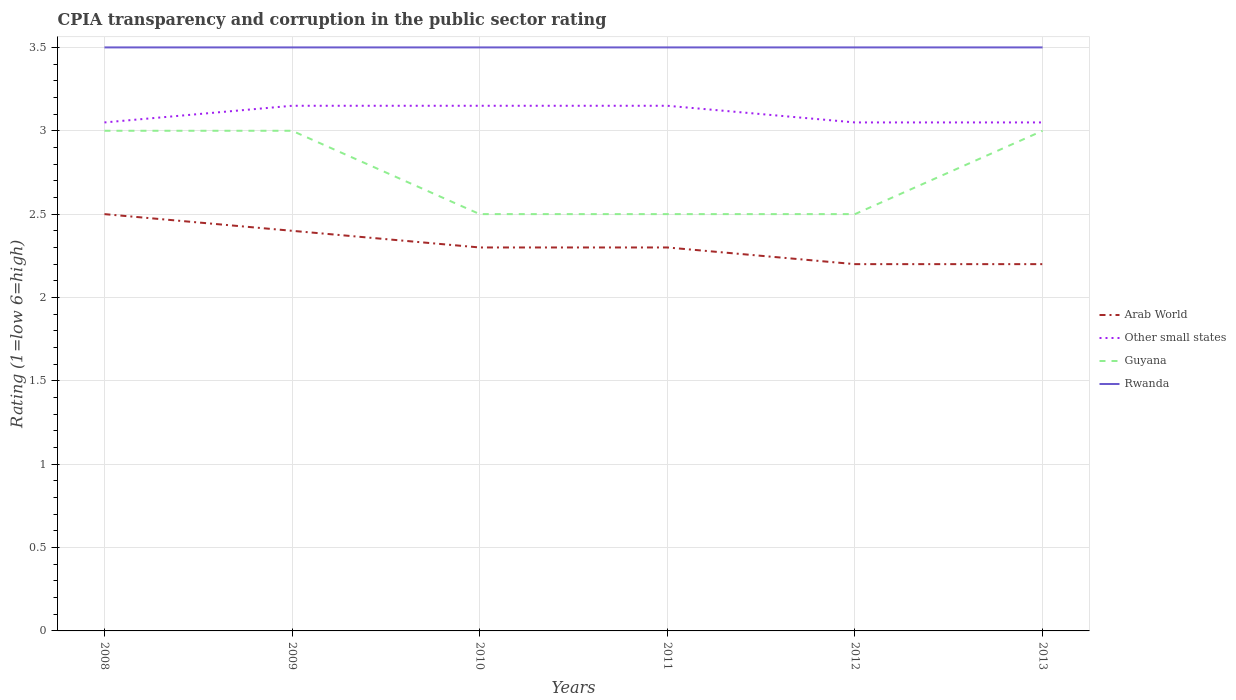Across all years, what is the maximum CPIA rating in Arab World?
Give a very brief answer. 2.2. In which year was the CPIA rating in Arab World maximum?
Your answer should be compact. 2012. What is the total CPIA rating in Arab World in the graph?
Provide a short and direct response. 0.3. What is the difference between the highest and the second highest CPIA rating in Other small states?
Your answer should be compact. 0.1. Is the CPIA rating in Other small states strictly greater than the CPIA rating in Rwanda over the years?
Give a very brief answer. Yes. How many years are there in the graph?
Your answer should be compact. 6. What is the difference between two consecutive major ticks on the Y-axis?
Offer a very short reply. 0.5. Does the graph contain any zero values?
Keep it short and to the point. No. Does the graph contain grids?
Keep it short and to the point. Yes. How are the legend labels stacked?
Your answer should be compact. Vertical. What is the title of the graph?
Ensure brevity in your answer.  CPIA transparency and corruption in the public sector rating. What is the label or title of the Y-axis?
Offer a terse response. Rating (1=low 6=high). What is the Rating (1=low 6=high) of Other small states in 2008?
Offer a very short reply. 3.05. What is the Rating (1=low 6=high) of Guyana in 2008?
Your response must be concise. 3. What is the Rating (1=low 6=high) in Rwanda in 2008?
Provide a succinct answer. 3.5. What is the Rating (1=low 6=high) of Arab World in 2009?
Ensure brevity in your answer.  2.4. What is the Rating (1=low 6=high) of Other small states in 2009?
Provide a succinct answer. 3.15. What is the Rating (1=low 6=high) of Other small states in 2010?
Your answer should be very brief. 3.15. What is the Rating (1=low 6=high) in Other small states in 2011?
Offer a terse response. 3.15. What is the Rating (1=low 6=high) in Guyana in 2011?
Offer a very short reply. 2.5. What is the Rating (1=low 6=high) of Other small states in 2012?
Your answer should be very brief. 3.05. What is the Rating (1=low 6=high) in Rwanda in 2012?
Give a very brief answer. 3.5. What is the Rating (1=low 6=high) in Arab World in 2013?
Offer a very short reply. 2.2. What is the Rating (1=low 6=high) of Other small states in 2013?
Provide a succinct answer. 3.05. What is the Rating (1=low 6=high) of Guyana in 2013?
Provide a succinct answer. 3. Across all years, what is the maximum Rating (1=low 6=high) in Arab World?
Your answer should be very brief. 2.5. Across all years, what is the maximum Rating (1=low 6=high) of Other small states?
Keep it short and to the point. 3.15. Across all years, what is the minimum Rating (1=low 6=high) of Other small states?
Give a very brief answer. 3.05. Across all years, what is the minimum Rating (1=low 6=high) in Guyana?
Offer a very short reply. 2.5. Across all years, what is the minimum Rating (1=low 6=high) of Rwanda?
Offer a very short reply. 3.5. What is the total Rating (1=low 6=high) in Arab World in the graph?
Offer a very short reply. 13.9. What is the total Rating (1=low 6=high) of Guyana in the graph?
Your response must be concise. 16.5. What is the difference between the Rating (1=low 6=high) of Arab World in 2008 and that in 2009?
Your answer should be compact. 0.1. What is the difference between the Rating (1=low 6=high) of Other small states in 2008 and that in 2009?
Provide a short and direct response. -0.1. What is the difference between the Rating (1=low 6=high) in Guyana in 2008 and that in 2009?
Your answer should be compact. 0. What is the difference between the Rating (1=low 6=high) of Rwanda in 2008 and that in 2009?
Ensure brevity in your answer.  0. What is the difference between the Rating (1=low 6=high) of Arab World in 2008 and that in 2010?
Ensure brevity in your answer.  0.2. What is the difference between the Rating (1=low 6=high) of Other small states in 2008 and that in 2010?
Provide a short and direct response. -0.1. What is the difference between the Rating (1=low 6=high) in Guyana in 2008 and that in 2010?
Your response must be concise. 0.5. What is the difference between the Rating (1=low 6=high) in Rwanda in 2008 and that in 2010?
Make the answer very short. 0. What is the difference between the Rating (1=low 6=high) of Other small states in 2008 and that in 2011?
Your response must be concise. -0.1. What is the difference between the Rating (1=low 6=high) of Guyana in 2008 and that in 2011?
Your response must be concise. 0.5. What is the difference between the Rating (1=low 6=high) of Rwanda in 2008 and that in 2011?
Your response must be concise. 0. What is the difference between the Rating (1=low 6=high) in Guyana in 2008 and that in 2012?
Provide a succinct answer. 0.5. What is the difference between the Rating (1=low 6=high) of Arab World in 2008 and that in 2013?
Your answer should be very brief. 0.3. What is the difference between the Rating (1=low 6=high) of Guyana in 2008 and that in 2013?
Provide a succinct answer. 0. What is the difference between the Rating (1=low 6=high) in Rwanda in 2009 and that in 2010?
Provide a succinct answer. 0. What is the difference between the Rating (1=low 6=high) of Arab World in 2009 and that in 2011?
Give a very brief answer. 0.1. What is the difference between the Rating (1=low 6=high) in Other small states in 2009 and that in 2011?
Provide a short and direct response. 0. What is the difference between the Rating (1=low 6=high) in Other small states in 2009 and that in 2012?
Make the answer very short. 0.1. What is the difference between the Rating (1=low 6=high) of Rwanda in 2009 and that in 2012?
Ensure brevity in your answer.  0. What is the difference between the Rating (1=low 6=high) in Arab World in 2009 and that in 2013?
Your answer should be very brief. 0.2. What is the difference between the Rating (1=low 6=high) of Arab World in 2010 and that in 2011?
Your answer should be compact. 0. What is the difference between the Rating (1=low 6=high) in Guyana in 2010 and that in 2012?
Offer a very short reply. 0. What is the difference between the Rating (1=low 6=high) of Other small states in 2010 and that in 2013?
Offer a very short reply. 0.1. What is the difference between the Rating (1=low 6=high) of Rwanda in 2010 and that in 2013?
Your answer should be compact. 0. What is the difference between the Rating (1=low 6=high) of Arab World in 2011 and that in 2012?
Provide a short and direct response. 0.1. What is the difference between the Rating (1=low 6=high) in Other small states in 2011 and that in 2012?
Offer a terse response. 0.1. What is the difference between the Rating (1=low 6=high) of Rwanda in 2011 and that in 2012?
Provide a short and direct response. 0. What is the difference between the Rating (1=low 6=high) in Other small states in 2011 and that in 2013?
Your response must be concise. 0.1. What is the difference between the Rating (1=low 6=high) of Rwanda in 2011 and that in 2013?
Your answer should be very brief. 0. What is the difference between the Rating (1=low 6=high) in Rwanda in 2012 and that in 2013?
Your answer should be compact. 0. What is the difference between the Rating (1=low 6=high) in Arab World in 2008 and the Rating (1=low 6=high) in Other small states in 2009?
Your response must be concise. -0.65. What is the difference between the Rating (1=low 6=high) in Arab World in 2008 and the Rating (1=low 6=high) in Guyana in 2009?
Ensure brevity in your answer.  -0.5. What is the difference between the Rating (1=low 6=high) in Arab World in 2008 and the Rating (1=low 6=high) in Rwanda in 2009?
Provide a succinct answer. -1. What is the difference between the Rating (1=low 6=high) of Other small states in 2008 and the Rating (1=low 6=high) of Rwanda in 2009?
Provide a short and direct response. -0.45. What is the difference between the Rating (1=low 6=high) of Guyana in 2008 and the Rating (1=low 6=high) of Rwanda in 2009?
Offer a terse response. -0.5. What is the difference between the Rating (1=low 6=high) in Arab World in 2008 and the Rating (1=low 6=high) in Other small states in 2010?
Ensure brevity in your answer.  -0.65. What is the difference between the Rating (1=low 6=high) of Arab World in 2008 and the Rating (1=low 6=high) of Guyana in 2010?
Provide a succinct answer. 0. What is the difference between the Rating (1=low 6=high) of Arab World in 2008 and the Rating (1=low 6=high) of Rwanda in 2010?
Your answer should be very brief. -1. What is the difference between the Rating (1=low 6=high) of Other small states in 2008 and the Rating (1=low 6=high) of Guyana in 2010?
Keep it short and to the point. 0.55. What is the difference between the Rating (1=low 6=high) in Other small states in 2008 and the Rating (1=low 6=high) in Rwanda in 2010?
Keep it short and to the point. -0.45. What is the difference between the Rating (1=low 6=high) of Guyana in 2008 and the Rating (1=low 6=high) of Rwanda in 2010?
Your answer should be compact. -0.5. What is the difference between the Rating (1=low 6=high) of Arab World in 2008 and the Rating (1=low 6=high) of Other small states in 2011?
Ensure brevity in your answer.  -0.65. What is the difference between the Rating (1=low 6=high) of Arab World in 2008 and the Rating (1=low 6=high) of Rwanda in 2011?
Offer a terse response. -1. What is the difference between the Rating (1=low 6=high) of Other small states in 2008 and the Rating (1=low 6=high) of Guyana in 2011?
Your response must be concise. 0.55. What is the difference between the Rating (1=low 6=high) in Other small states in 2008 and the Rating (1=low 6=high) in Rwanda in 2011?
Give a very brief answer. -0.45. What is the difference between the Rating (1=low 6=high) of Arab World in 2008 and the Rating (1=low 6=high) of Other small states in 2012?
Your answer should be very brief. -0.55. What is the difference between the Rating (1=low 6=high) in Other small states in 2008 and the Rating (1=low 6=high) in Guyana in 2012?
Offer a terse response. 0.55. What is the difference between the Rating (1=low 6=high) in Other small states in 2008 and the Rating (1=low 6=high) in Rwanda in 2012?
Give a very brief answer. -0.45. What is the difference between the Rating (1=low 6=high) in Arab World in 2008 and the Rating (1=low 6=high) in Other small states in 2013?
Offer a terse response. -0.55. What is the difference between the Rating (1=low 6=high) in Other small states in 2008 and the Rating (1=low 6=high) in Guyana in 2013?
Your answer should be compact. 0.05. What is the difference between the Rating (1=low 6=high) of Other small states in 2008 and the Rating (1=low 6=high) of Rwanda in 2013?
Your answer should be compact. -0.45. What is the difference between the Rating (1=low 6=high) in Guyana in 2008 and the Rating (1=low 6=high) in Rwanda in 2013?
Keep it short and to the point. -0.5. What is the difference between the Rating (1=low 6=high) of Arab World in 2009 and the Rating (1=low 6=high) of Other small states in 2010?
Make the answer very short. -0.75. What is the difference between the Rating (1=low 6=high) in Arab World in 2009 and the Rating (1=low 6=high) in Guyana in 2010?
Offer a very short reply. -0.1. What is the difference between the Rating (1=low 6=high) of Arab World in 2009 and the Rating (1=low 6=high) of Rwanda in 2010?
Provide a succinct answer. -1.1. What is the difference between the Rating (1=low 6=high) of Other small states in 2009 and the Rating (1=low 6=high) of Guyana in 2010?
Ensure brevity in your answer.  0.65. What is the difference between the Rating (1=low 6=high) of Other small states in 2009 and the Rating (1=low 6=high) of Rwanda in 2010?
Your response must be concise. -0.35. What is the difference between the Rating (1=low 6=high) in Guyana in 2009 and the Rating (1=low 6=high) in Rwanda in 2010?
Keep it short and to the point. -0.5. What is the difference between the Rating (1=low 6=high) in Arab World in 2009 and the Rating (1=low 6=high) in Other small states in 2011?
Your answer should be very brief. -0.75. What is the difference between the Rating (1=low 6=high) of Other small states in 2009 and the Rating (1=low 6=high) of Guyana in 2011?
Make the answer very short. 0.65. What is the difference between the Rating (1=low 6=high) in Other small states in 2009 and the Rating (1=low 6=high) in Rwanda in 2011?
Keep it short and to the point. -0.35. What is the difference between the Rating (1=low 6=high) of Guyana in 2009 and the Rating (1=low 6=high) of Rwanda in 2011?
Provide a short and direct response. -0.5. What is the difference between the Rating (1=low 6=high) of Arab World in 2009 and the Rating (1=low 6=high) of Other small states in 2012?
Make the answer very short. -0.65. What is the difference between the Rating (1=low 6=high) in Arab World in 2009 and the Rating (1=low 6=high) in Guyana in 2012?
Provide a short and direct response. -0.1. What is the difference between the Rating (1=low 6=high) in Arab World in 2009 and the Rating (1=low 6=high) in Rwanda in 2012?
Provide a short and direct response. -1.1. What is the difference between the Rating (1=low 6=high) of Other small states in 2009 and the Rating (1=low 6=high) of Guyana in 2012?
Ensure brevity in your answer.  0.65. What is the difference between the Rating (1=low 6=high) in Other small states in 2009 and the Rating (1=low 6=high) in Rwanda in 2012?
Your response must be concise. -0.35. What is the difference between the Rating (1=low 6=high) of Arab World in 2009 and the Rating (1=low 6=high) of Other small states in 2013?
Ensure brevity in your answer.  -0.65. What is the difference between the Rating (1=low 6=high) of Other small states in 2009 and the Rating (1=low 6=high) of Rwanda in 2013?
Your response must be concise. -0.35. What is the difference between the Rating (1=low 6=high) in Guyana in 2009 and the Rating (1=low 6=high) in Rwanda in 2013?
Your answer should be very brief. -0.5. What is the difference between the Rating (1=low 6=high) in Arab World in 2010 and the Rating (1=low 6=high) in Other small states in 2011?
Make the answer very short. -0.85. What is the difference between the Rating (1=low 6=high) of Arab World in 2010 and the Rating (1=low 6=high) of Guyana in 2011?
Your answer should be very brief. -0.2. What is the difference between the Rating (1=low 6=high) of Other small states in 2010 and the Rating (1=low 6=high) of Guyana in 2011?
Your response must be concise. 0.65. What is the difference between the Rating (1=low 6=high) in Other small states in 2010 and the Rating (1=low 6=high) in Rwanda in 2011?
Offer a terse response. -0.35. What is the difference between the Rating (1=low 6=high) in Arab World in 2010 and the Rating (1=low 6=high) in Other small states in 2012?
Your answer should be compact. -0.75. What is the difference between the Rating (1=low 6=high) of Arab World in 2010 and the Rating (1=low 6=high) of Guyana in 2012?
Your answer should be very brief. -0.2. What is the difference between the Rating (1=low 6=high) in Other small states in 2010 and the Rating (1=low 6=high) in Guyana in 2012?
Offer a very short reply. 0.65. What is the difference between the Rating (1=low 6=high) in Other small states in 2010 and the Rating (1=low 6=high) in Rwanda in 2012?
Your response must be concise. -0.35. What is the difference between the Rating (1=low 6=high) in Guyana in 2010 and the Rating (1=low 6=high) in Rwanda in 2012?
Offer a terse response. -1. What is the difference between the Rating (1=low 6=high) of Arab World in 2010 and the Rating (1=low 6=high) of Other small states in 2013?
Provide a short and direct response. -0.75. What is the difference between the Rating (1=low 6=high) of Arab World in 2010 and the Rating (1=low 6=high) of Guyana in 2013?
Keep it short and to the point. -0.7. What is the difference between the Rating (1=low 6=high) of Arab World in 2010 and the Rating (1=low 6=high) of Rwanda in 2013?
Offer a terse response. -1.2. What is the difference between the Rating (1=low 6=high) in Other small states in 2010 and the Rating (1=low 6=high) in Guyana in 2013?
Give a very brief answer. 0.15. What is the difference between the Rating (1=low 6=high) of Other small states in 2010 and the Rating (1=low 6=high) of Rwanda in 2013?
Offer a terse response. -0.35. What is the difference between the Rating (1=low 6=high) in Arab World in 2011 and the Rating (1=low 6=high) in Other small states in 2012?
Make the answer very short. -0.75. What is the difference between the Rating (1=low 6=high) in Other small states in 2011 and the Rating (1=low 6=high) in Guyana in 2012?
Provide a succinct answer. 0.65. What is the difference between the Rating (1=low 6=high) in Other small states in 2011 and the Rating (1=low 6=high) in Rwanda in 2012?
Make the answer very short. -0.35. What is the difference between the Rating (1=low 6=high) of Arab World in 2011 and the Rating (1=low 6=high) of Other small states in 2013?
Give a very brief answer. -0.75. What is the difference between the Rating (1=low 6=high) in Arab World in 2011 and the Rating (1=low 6=high) in Rwanda in 2013?
Offer a terse response. -1.2. What is the difference between the Rating (1=low 6=high) in Other small states in 2011 and the Rating (1=low 6=high) in Rwanda in 2013?
Your answer should be compact. -0.35. What is the difference between the Rating (1=low 6=high) of Arab World in 2012 and the Rating (1=low 6=high) of Other small states in 2013?
Keep it short and to the point. -0.85. What is the difference between the Rating (1=low 6=high) in Other small states in 2012 and the Rating (1=low 6=high) in Guyana in 2013?
Keep it short and to the point. 0.05. What is the difference between the Rating (1=low 6=high) of Other small states in 2012 and the Rating (1=low 6=high) of Rwanda in 2013?
Offer a very short reply. -0.45. What is the average Rating (1=low 6=high) in Arab World per year?
Offer a very short reply. 2.32. What is the average Rating (1=low 6=high) of Guyana per year?
Keep it short and to the point. 2.75. What is the average Rating (1=low 6=high) of Rwanda per year?
Provide a succinct answer. 3.5. In the year 2008, what is the difference between the Rating (1=low 6=high) in Arab World and Rating (1=low 6=high) in Other small states?
Provide a succinct answer. -0.55. In the year 2008, what is the difference between the Rating (1=low 6=high) of Other small states and Rating (1=low 6=high) of Rwanda?
Make the answer very short. -0.45. In the year 2009, what is the difference between the Rating (1=low 6=high) in Arab World and Rating (1=low 6=high) in Other small states?
Offer a very short reply. -0.75. In the year 2009, what is the difference between the Rating (1=low 6=high) in Arab World and Rating (1=low 6=high) in Guyana?
Make the answer very short. -0.6. In the year 2009, what is the difference between the Rating (1=low 6=high) of Arab World and Rating (1=low 6=high) of Rwanda?
Your answer should be compact. -1.1. In the year 2009, what is the difference between the Rating (1=low 6=high) in Other small states and Rating (1=low 6=high) in Guyana?
Make the answer very short. 0.15. In the year 2009, what is the difference between the Rating (1=low 6=high) in Other small states and Rating (1=low 6=high) in Rwanda?
Give a very brief answer. -0.35. In the year 2009, what is the difference between the Rating (1=low 6=high) in Guyana and Rating (1=low 6=high) in Rwanda?
Your answer should be compact. -0.5. In the year 2010, what is the difference between the Rating (1=low 6=high) in Arab World and Rating (1=low 6=high) in Other small states?
Make the answer very short. -0.85. In the year 2010, what is the difference between the Rating (1=low 6=high) of Arab World and Rating (1=low 6=high) of Guyana?
Offer a terse response. -0.2. In the year 2010, what is the difference between the Rating (1=low 6=high) of Other small states and Rating (1=low 6=high) of Guyana?
Give a very brief answer. 0.65. In the year 2010, what is the difference between the Rating (1=low 6=high) of Other small states and Rating (1=low 6=high) of Rwanda?
Provide a short and direct response. -0.35. In the year 2010, what is the difference between the Rating (1=low 6=high) in Guyana and Rating (1=low 6=high) in Rwanda?
Make the answer very short. -1. In the year 2011, what is the difference between the Rating (1=low 6=high) of Arab World and Rating (1=low 6=high) of Other small states?
Your answer should be compact. -0.85. In the year 2011, what is the difference between the Rating (1=low 6=high) of Arab World and Rating (1=low 6=high) of Rwanda?
Ensure brevity in your answer.  -1.2. In the year 2011, what is the difference between the Rating (1=low 6=high) of Other small states and Rating (1=low 6=high) of Guyana?
Provide a short and direct response. 0.65. In the year 2011, what is the difference between the Rating (1=low 6=high) of Other small states and Rating (1=low 6=high) of Rwanda?
Offer a very short reply. -0.35. In the year 2011, what is the difference between the Rating (1=low 6=high) of Guyana and Rating (1=low 6=high) of Rwanda?
Offer a terse response. -1. In the year 2012, what is the difference between the Rating (1=low 6=high) in Arab World and Rating (1=low 6=high) in Other small states?
Your answer should be very brief. -0.85. In the year 2012, what is the difference between the Rating (1=low 6=high) in Arab World and Rating (1=low 6=high) in Guyana?
Ensure brevity in your answer.  -0.3. In the year 2012, what is the difference between the Rating (1=low 6=high) in Arab World and Rating (1=low 6=high) in Rwanda?
Provide a short and direct response. -1.3. In the year 2012, what is the difference between the Rating (1=low 6=high) of Other small states and Rating (1=low 6=high) of Guyana?
Provide a succinct answer. 0.55. In the year 2012, what is the difference between the Rating (1=low 6=high) in Other small states and Rating (1=low 6=high) in Rwanda?
Offer a very short reply. -0.45. In the year 2012, what is the difference between the Rating (1=low 6=high) of Guyana and Rating (1=low 6=high) of Rwanda?
Ensure brevity in your answer.  -1. In the year 2013, what is the difference between the Rating (1=low 6=high) of Arab World and Rating (1=low 6=high) of Other small states?
Ensure brevity in your answer.  -0.85. In the year 2013, what is the difference between the Rating (1=low 6=high) in Arab World and Rating (1=low 6=high) in Guyana?
Give a very brief answer. -0.8. In the year 2013, what is the difference between the Rating (1=low 6=high) of Arab World and Rating (1=low 6=high) of Rwanda?
Keep it short and to the point. -1.3. In the year 2013, what is the difference between the Rating (1=low 6=high) in Other small states and Rating (1=low 6=high) in Rwanda?
Offer a very short reply. -0.45. In the year 2013, what is the difference between the Rating (1=low 6=high) of Guyana and Rating (1=low 6=high) of Rwanda?
Make the answer very short. -0.5. What is the ratio of the Rating (1=low 6=high) of Arab World in 2008 to that in 2009?
Give a very brief answer. 1.04. What is the ratio of the Rating (1=low 6=high) in Other small states in 2008 to that in 2009?
Your answer should be compact. 0.97. What is the ratio of the Rating (1=low 6=high) of Arab World in 2008 to that in 2010?
Give a very brief answer. 1.09. What is the ratio of the Rating (1=low 6=high) in Other small states in 2008 to that in 2010?
Offer a terse response. 0.97. What is the ratio of the Rating (1=low 6=high) in Arab World in 2008 to that in 2011?
Ensure brevity in your answer.  1.09. What is the ratio of the Rating (1=low 6=high) in Other small states in 2008 to that in 2011?
Provide a succinct answer. 0.97. What is the ratio of the Rating (1=low 6=high) in Guyana in 2008 to that in 2011?
Provide a short and direct response. 1.2. What is the ratio of the Rating (1=low 6=high) in Arab World in 2008 to that in 2012?
Your answer should be very brief. 1.14. What is the ratio of the Rating (1=low 6=high) of Guyana in 2008 to that in 2012?
Offer a terse response. 1.2. What is the ratio of the Rating (1=low 6=high) in Rwanda in 2008 to that in 2012?
Your answer should be very brief. 1. What is the ratio of the Rating (1=low 6=high) in Arab World in 2008 to that in 2013?
Give a very brief answer. 1.14. What is the ratio of the Rating (1=low 6=high) of Other small states in 2008 to that in 2013?
Your answer should be compact. 1. What is the ratio of the Rating (1=low 6=high) of Rwanda in 2008 to that in 2013?
Provide a succinct answer. 1. What is the ratio of the Rating (1=low 6=high) of Arab World in 2009 to that in 2010?
Make the answer very short. 1.04. What is the ratio of the Rating (1=low 6=high) of Guyana in 2009 to that in 2010?
Offer a terse response. 1.2. What is the ratio of the Rating (1=low 6=high) in Arab World in 2009 to that in 2011?
Provide a short and direct response. 1.04. What is the ratio of the Rating (1=low 6=high) in Rwanda in 2009 to that in 2011?
Ensure brevity in your answer.  1. What is the ratio of the Rating (1=low 6=high) in Other small states in 2009 to that in 2012?
Your response must be concise. 1.03. What is the ratio of the Rating (1=low 6=high) of Guyana in 2009 to that in 2012?
Your answer should be very brief. 1.2. What is the ratio of the Rating (1=low 6=high) in Arab World in 2009 to that in 2013?
Offer a very short reply. 1.09. What is the ratio of the Rating (1=low 6=high) in Other small states in 2009 to that in 2013?
Your answer should be compact. 1.03. What is the ratio of the Rating (1=low 6=high) of Guyana in 2009 to that in 2013?
Your answer should be compact. 1. What is the ratio of the Rating (1=low 6=high) in Guyana in 2010 to that in 2011?
Your answer should be compact. 1. What is the ratio of the Rating (1=low 6=high) of Arab World in 2010 to that in 2012?
Provide a short and direct response. 1.05. What is the ratio of the Rating (1=low 6=high) of Other small states in 2010 to that in 2012?
Provide a short and direct response. 1.03. What is the ratio of the Rating (1=low 6=high) in Arab World in 2010 to that in 2013?
Provide a succinct answer. 1.05. What is the ratio of the Rating (1=low 6=high) in Other small states in 2010 to that in 2013?
Your response must be concise. 1.03. What is the ratio of the Rating (1=low 6=high) in Guyana in 2010 to that in 2013?
Ensure brevity in your answer.  0.83. What is the ratio of the Rating (1=low 6=high) of Rwanda in 2010 to that in 2013?
Keep it short and to the point. 1. What is the ratio of the Rating (1=low 6=high) of Arab World in 2011 to that in 2012?
Your response must be concise. 1.05. What is the ratio of the Rating (1=low 6=high) in Other small states in 2011 to that in 2012?
Your response must be concise. 1.03. What is the ratio of the Rating (1=low 6=high) in Guyana in 2011 to that in 2012?
Make the answer very short. 1. What is the ratio of the Rating (1=low 6=high) in Rwanda in 2011 to that in 2012?
Provide a succinct answer. 1. What is the ratio of the Rating (1=low 6=high) in Arab World in 2011 to that in 2013?
Your answer should be compact. 1.05. What is the ratio of the Rating (1=low 6=high) of Other small states in 2011 to that in 2013?
Offer a terse response. 1.03. What is the ratio of the Rating (1=low 6=high) of Rwanda in 2011 to that in 2013?
Give a very brief answer. 1. What is the ratio of the Rating (1=low 6=high) in Rwanda in 2012 to that in 2013?
Offer a terse response. 1. What is the difference between the highest and the second highest Rating (1=low 6=high) of Other small states?
Provide a short and direct response. 0. What is the difference between the highest and the lowest Rating (1=low 6=high) in Arab World?
Provide a short and direct response. 0.3. What is the difference between the highest and the lowest Rating (1=low 6=high) of Guyana?
Provide a succinct answer. 0.5. 